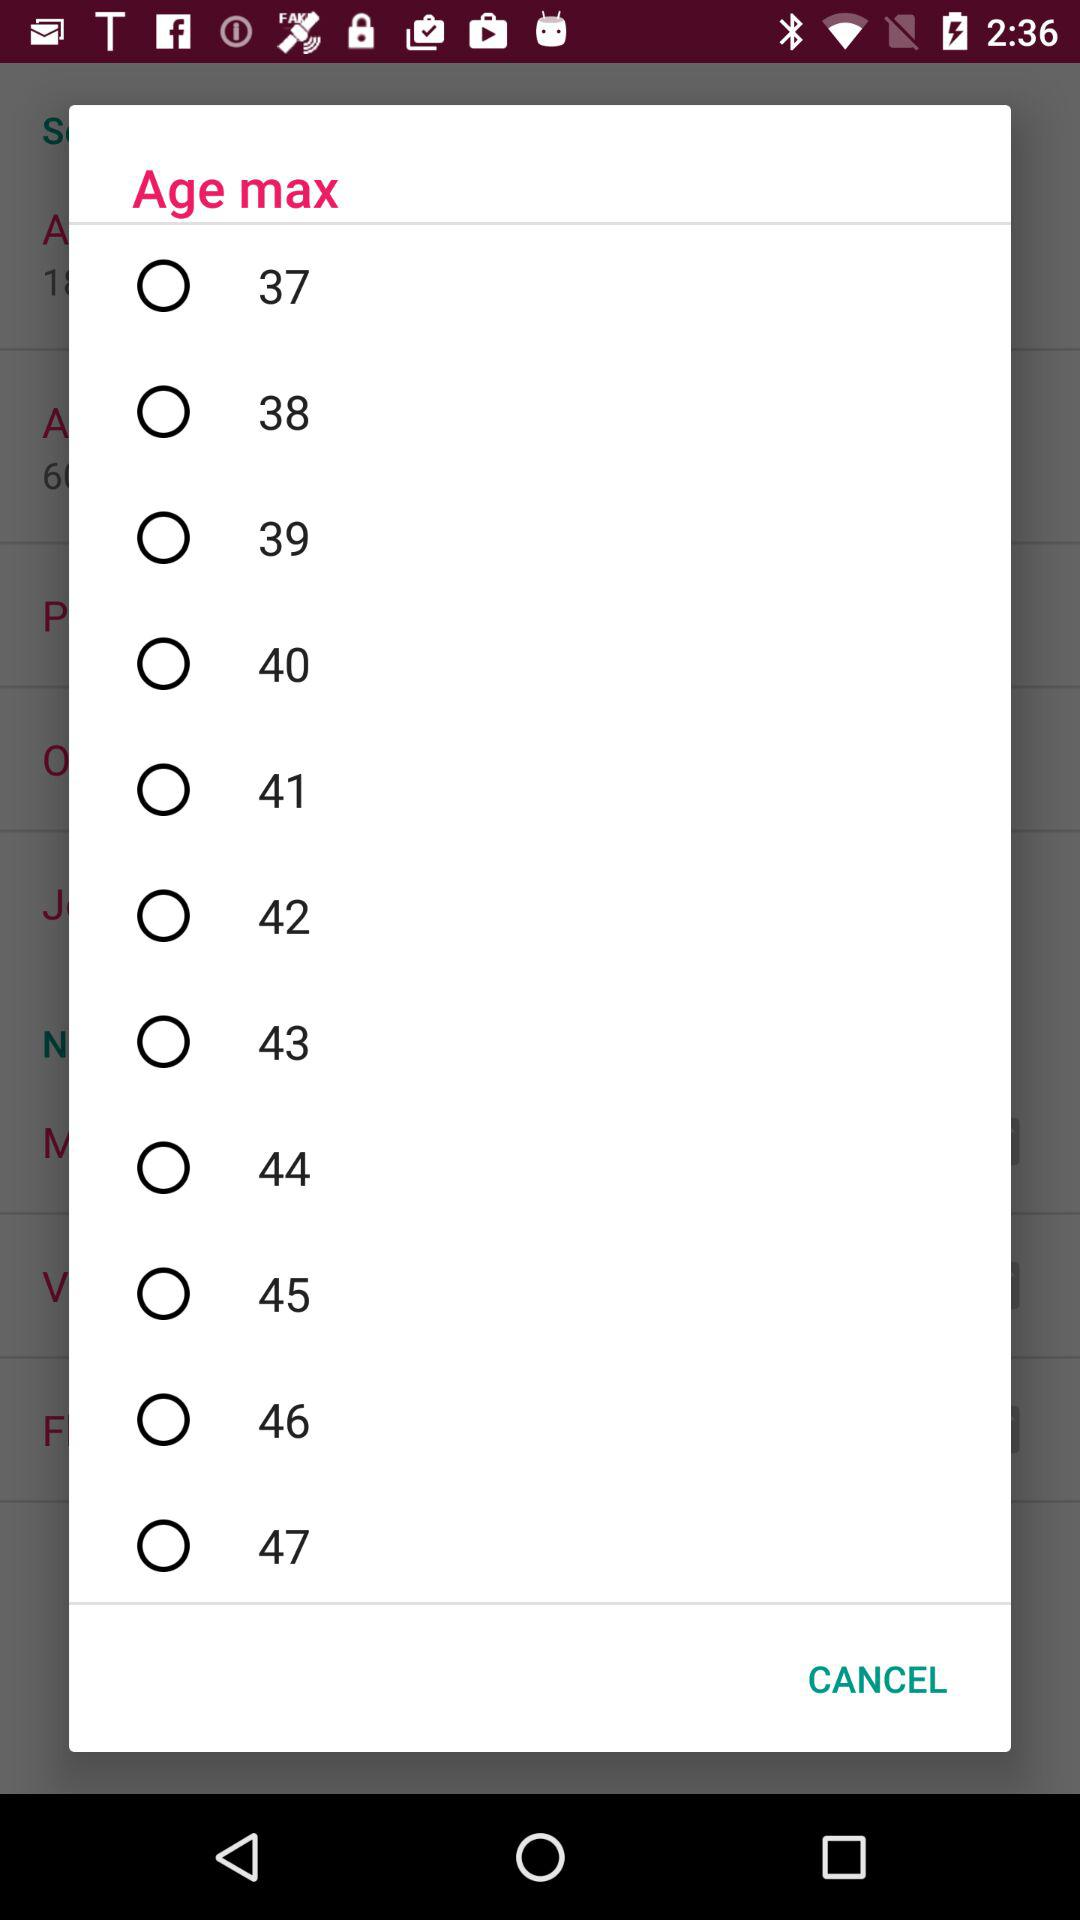What is the maximum age range? The maximum age range is 47. 